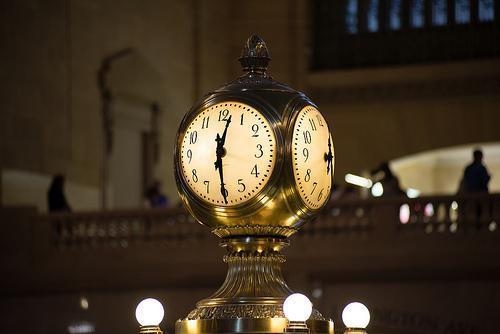How many balls of light are beneath the clock?
Give a very brief answer. 3. How many clock faces are there?
Give a very brief answer. 2. 